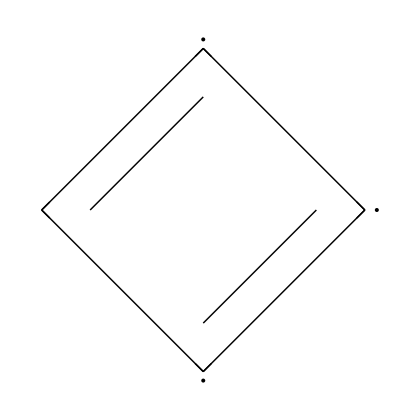What is the main element in this chemical? The chemical structure shows that carbon atoms are the primary atoms present, as evidenced by the notation of carbon in the SMILES representation.
Answer: carbon How many double bonds are present in this molecule? By analyzing the structure, there are three double bonds indicated in the SMILES, as denoted by the equal signs '=' between the carbon atoms.
Answer: three What type of structural feature is indicated by the alternating double bonds? The alternating double bonds suggest that this compound has a conjugated system, which is a characteristic of certain types of hydrocarbons often found in lubricants.
Answer: conjugated What is the common use of graphite powder in this context? Given its physical and chemical properties, graphite powder is commonly used as a dry lubricant, particularly for surfaces like wheelchair ramps, providing low-friction assistance.
Answer: dry lubricant Can this compound be classified as aromatic? Based on the structure displayed, it does not exhibit the necessary cyclic and resonance characteristics typically required for aromatic classification, despite having double bonds.
Answer: no 